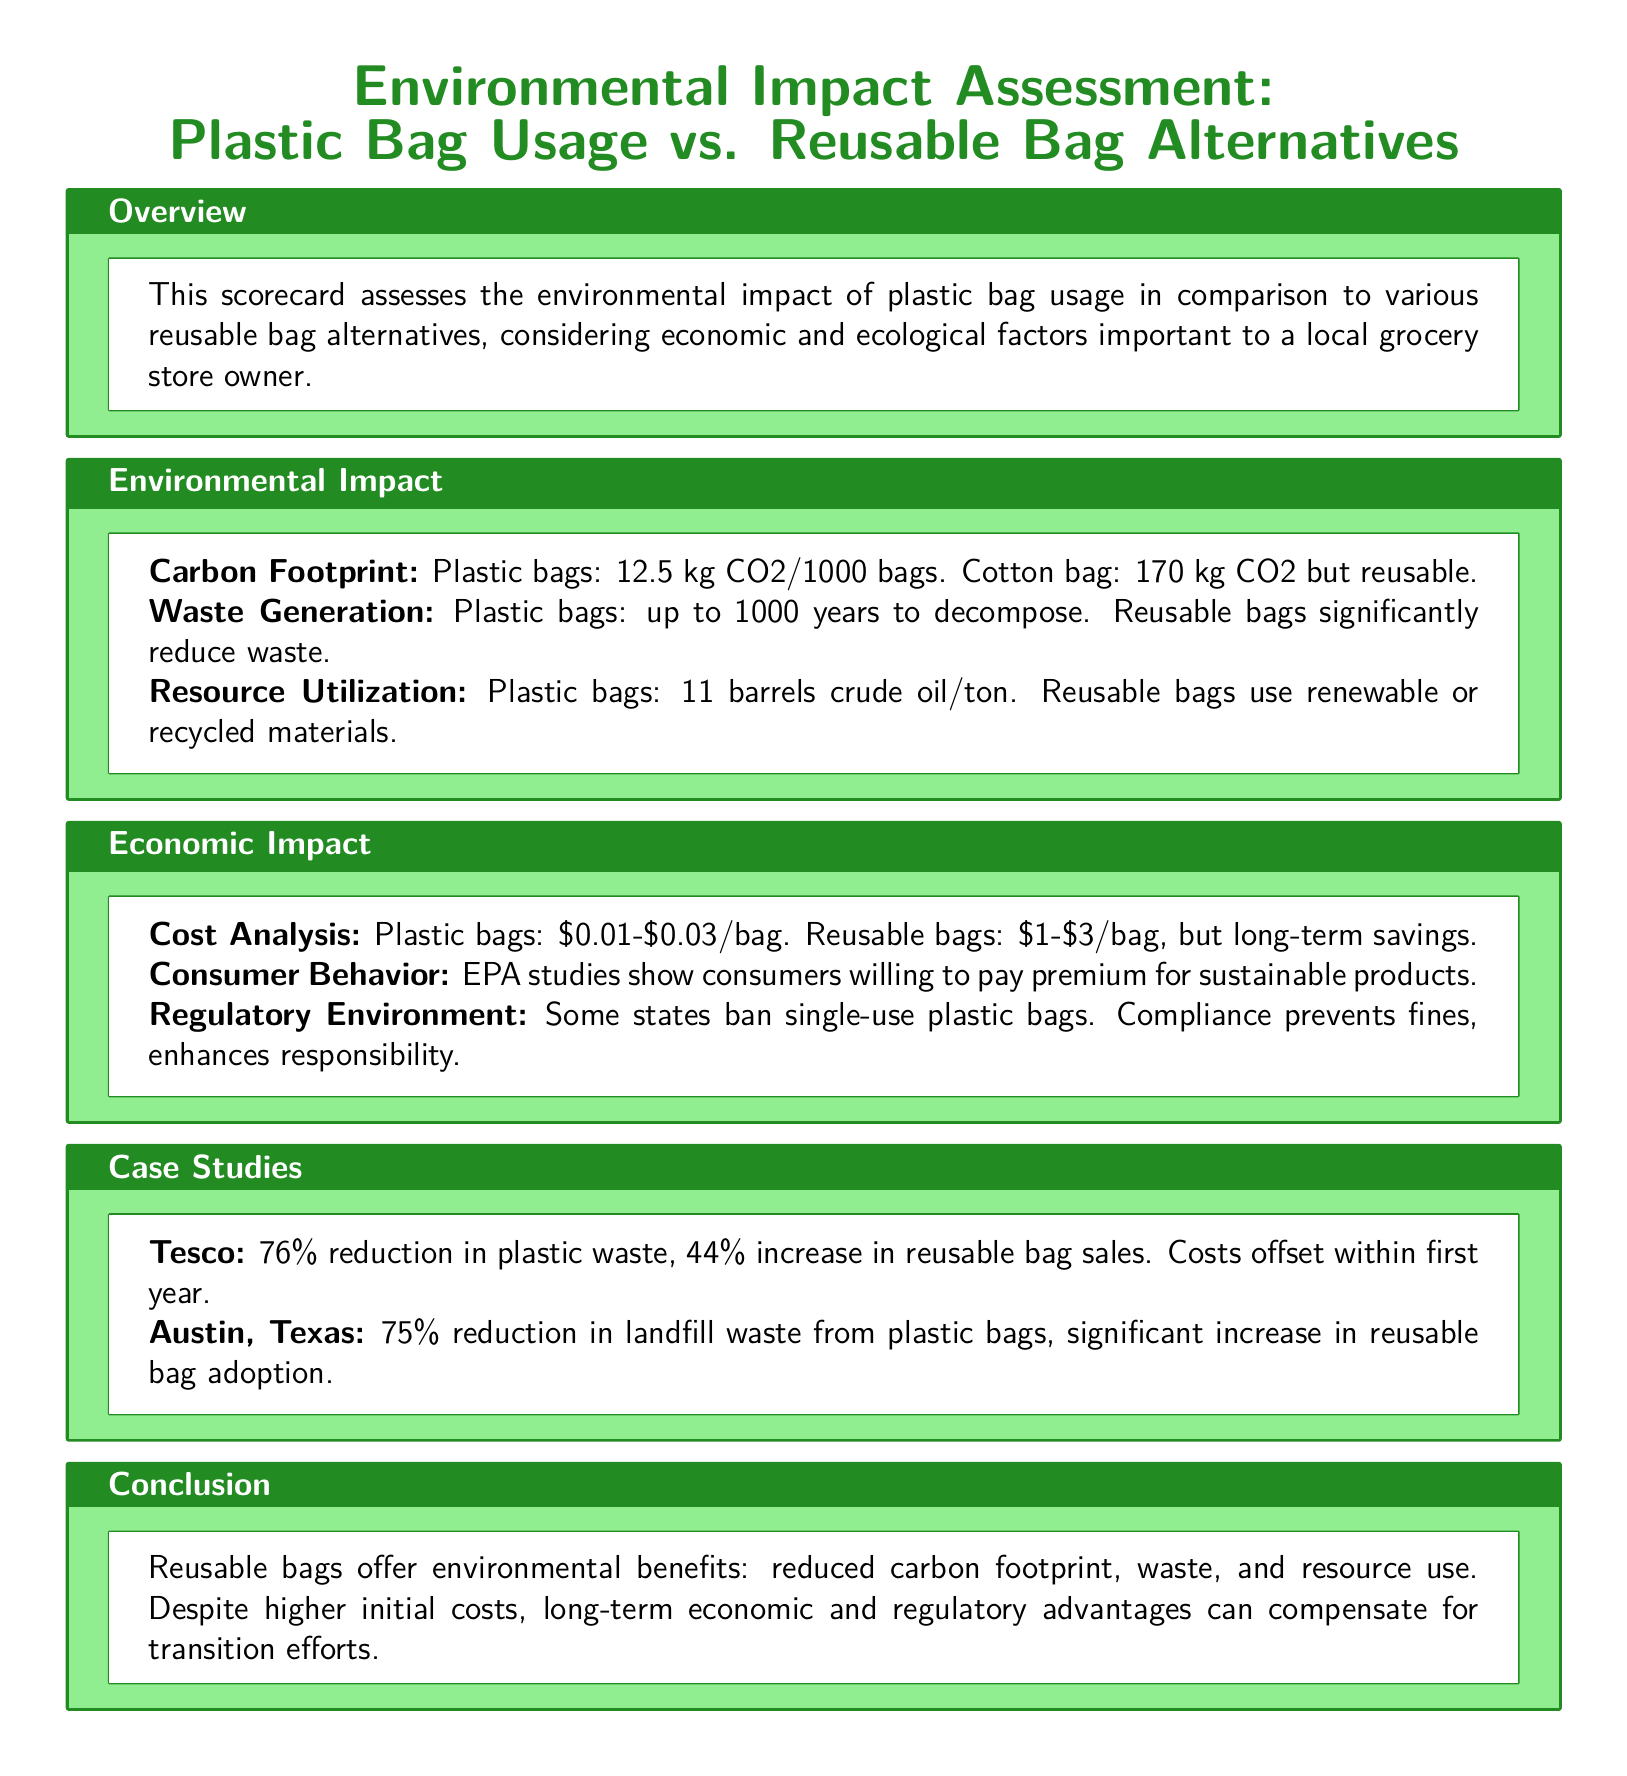What is the carbon footprint of plastic bags per 1000 bags? The document states that plastic bags have a carbon footprint of 12.5 kg CO2 per 1000 bags.
Answer: 12.5 kg CO2 How many years can plastic bags take to decompose? It is mentioned in the document that plastic bags can take up to 1000 years to decompose.
Answer: 1000 years What is the cost range of reusable bags? The scorecard specifies that reusable bags cost between $1 and $3.
Answer: $1-$3 What was the percentage reduction in plastic waste reported by Tesco? Tesco reported a 76% reduction in plastic waste.
Answer: 76% What is one of the motivations for consumers to purchase sustainable products? The EPA studies show that consumers are willing to pay a premium for sustainable products.
Answer: Willing to pay a premium In which city was a 75% reduction in landfill waste from plastic bags observed? The document mentions Austin, Texas, as the city with a 75% reduction in landfill waste.
Answer: Austin, Texas What type of materials do reusable bags use? Reusable bags utilize renewable or recycled materials according to the document.
Answer: Renewable or recycled materials What kind of environmental advantage do reusable bags offer? The document concludes that reusable bags offer a reduced carbon footprint.
Answer: Reduced carbon footprint 